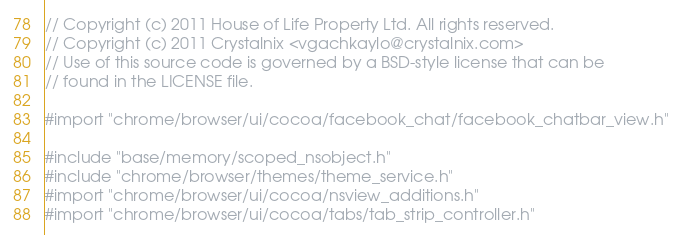<code> <loc_0><loc_0><loc_500><loc_500><_ObjectiveC_>// Copyright (c) 2011 House of Life Property Ltd. All rights reserved.
// Copyright (c) 2011 Crystalnix <vgachkaylo@crystalnix.com>
// Use of this source code is governed by a BSD-style license that can be
// found in the LICENSE file.

#import "chrome/browser/ui/cocoa/facebook_chat/facebook_chatbar_view.h"

#include "base/memory/scoped_nsobject.h"
#include "chrome/browser/themes/theme_service.h"
#import "chrome/browser/ui/cocoa/nsview_additions.h"
#import "chrome/browser/ui/cocoa/tabs/tab_strip_controller.h"</code> 